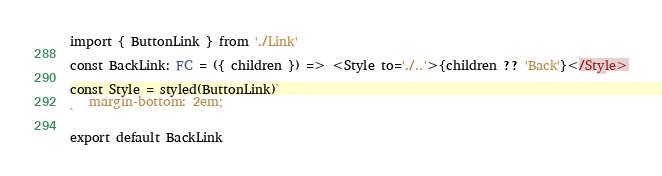Convert code to text. <code><loc_0><loc_0><loc_500><loc_500><_TypeScript_>import { ButtonLink } from './Link'

const BackLink: FC = ({ children }) => <Style to='./..'>{children ?? 'Back'}</Style>

const Style = styled(ButtonLink)`
   margin-bottom: 2em;
`

export default BackLink
</code> 